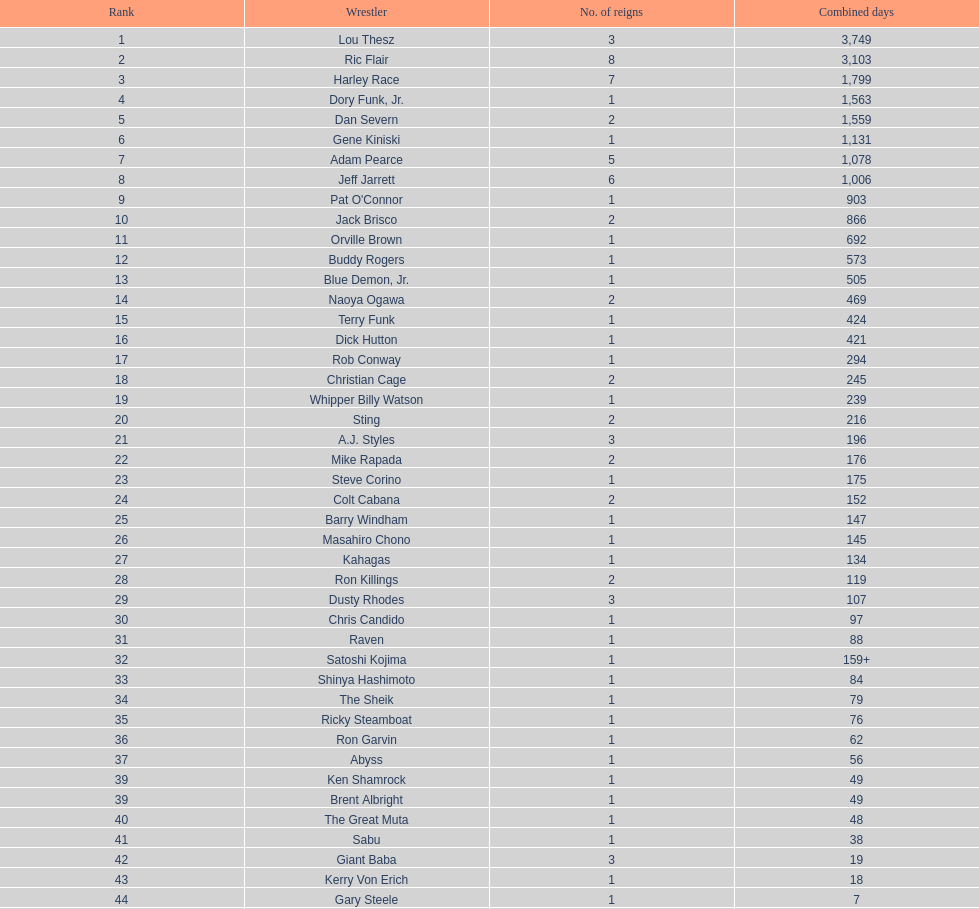Comparing the time spent as nwa world heavyweight champion, did gene kiniski or ric flair have a longer reign? Ric Flair. 